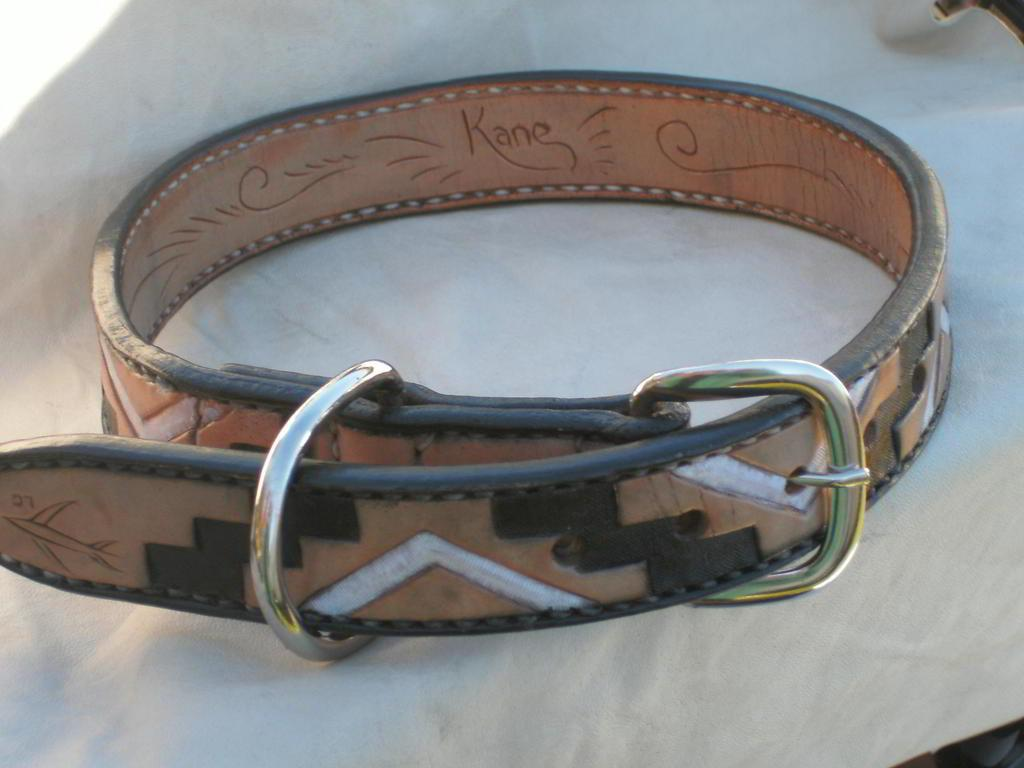<image>
Describe the image concisely. A leather belt with the name Kane on the inside is buckled. 